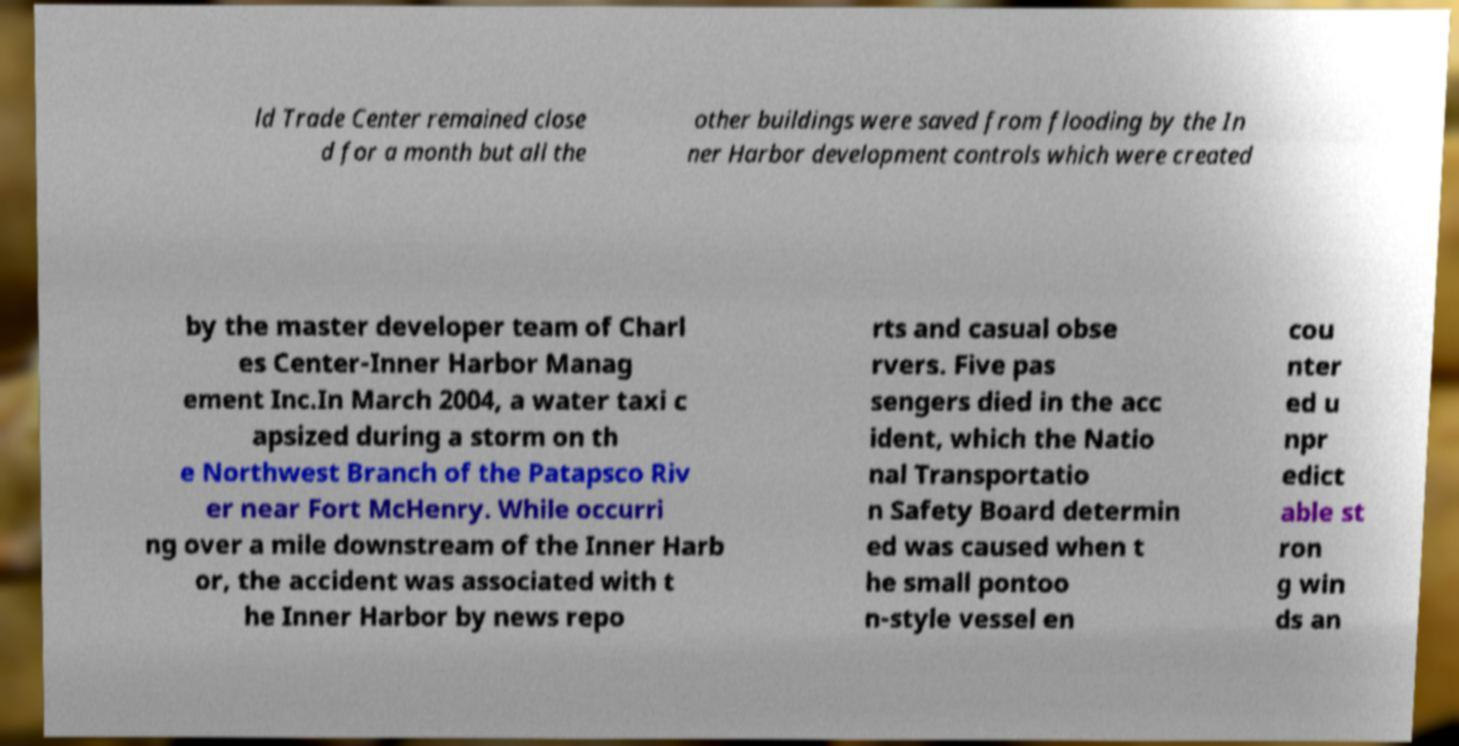Can you accurately transcribe the text from the provided image for me? ld Trade Center remained close d for a month but all the other buildings were saved from flooding by the In ner Harbor development controls which were created by the master developer team of Charl es Center-Inner Harbor Manag ement Inc.In March 2004, a water taxi c apsized during a storm on th e Northwest Branch of the Patapsco Riv er near Fort McHenry. While occurri ng over a mile downstream of the Inner Harb or, the accident was associated with t he Inner Harbor by news repo rts and casual obse rvers. Five pas sengers died in the acc ident, which the Natio nal Transportatio n Safety Board determin ed was caused when t he small pontoo n-style vessel en cou nter ed u npr edict able st ron g win ds an 